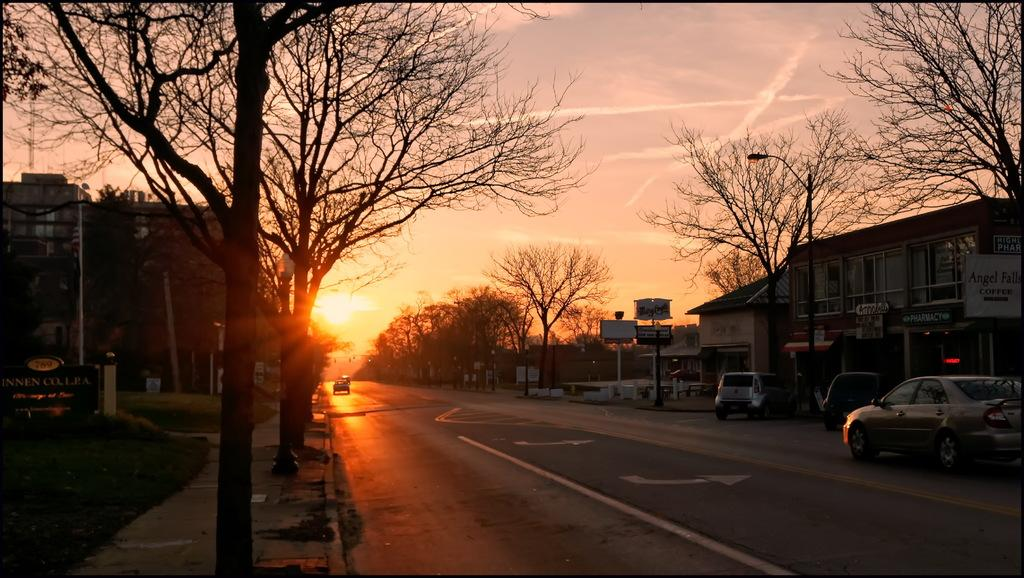What can be seen in the foreground of the image? There are fleets of cars in the foreground of the image. What type of structures are present in the image? There are buildings in the image. What type of vegetation is present in the image? Trees are present in the image. What type of lighting is visible in the image? Street lights are visible in the image. What type of signage is present in the image? Boards are present in the image. What type of pathway is present in the image? There is a road in the image. What is visible at the top of the image? The sky is visible at the top of the image. Where was the image taken? The image was taken on the road. How many clovers are growing on the road in the image? There are no clovers visible in the image; it features a road with cars, buildings, trees, and street lights. What type of yam is being sold on the boards in the image? There are no yams present in the image; it features boards with signage or advertisements. 